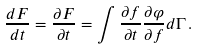Convert formula to latex. <formula><loc_0><loc_0><loc_500><loc_500>\frac { d F } { d t } = \frac { \partial F } { \partial t } = \int \frac { \partial f } { \partial t } \frac { \partial \varphi } { \partial f } d \Gamma \, .</formula> 